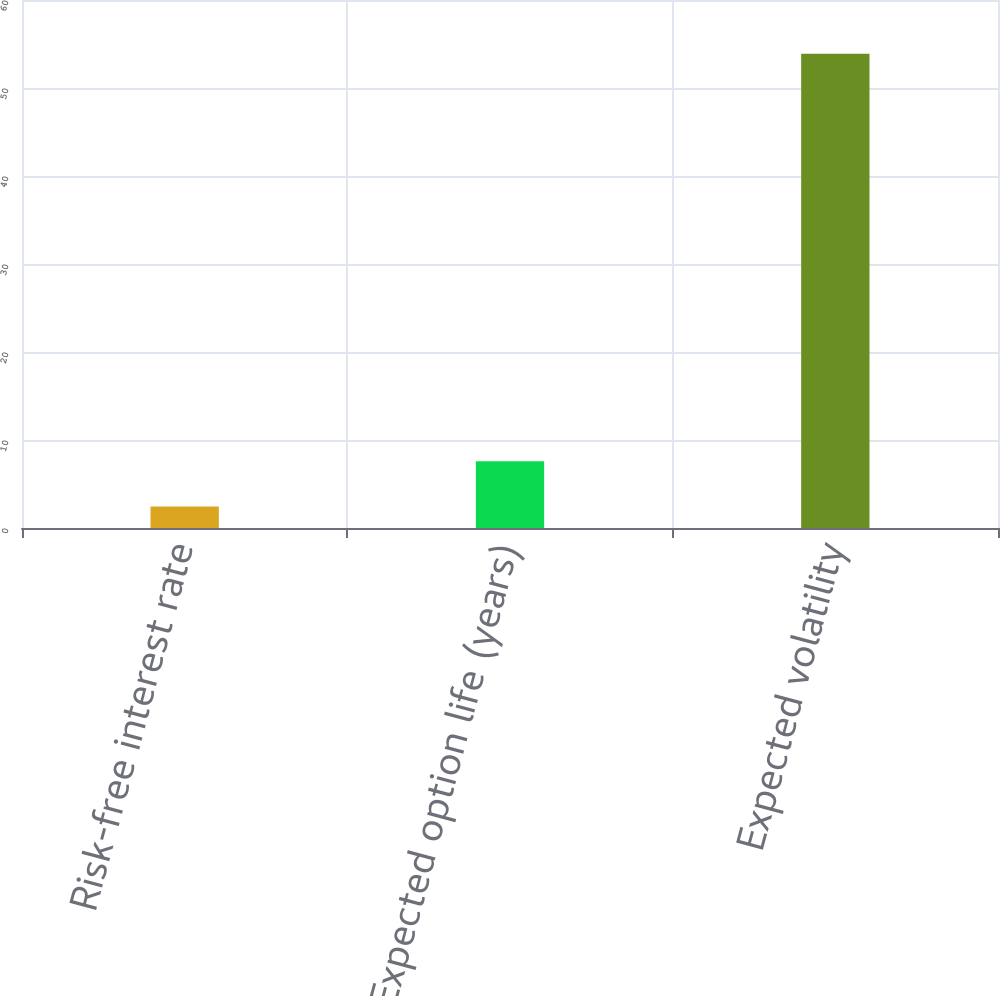<chart> <loc_0><loc_0><loc_500><loc_500><bar_chart><fcel>Risk-free interest rate<fcel>Expected option life (years)<fcel>Expected volatility<nl><fcel>2.45<fcel>7.59<fcel>53.9<nl></chart> 